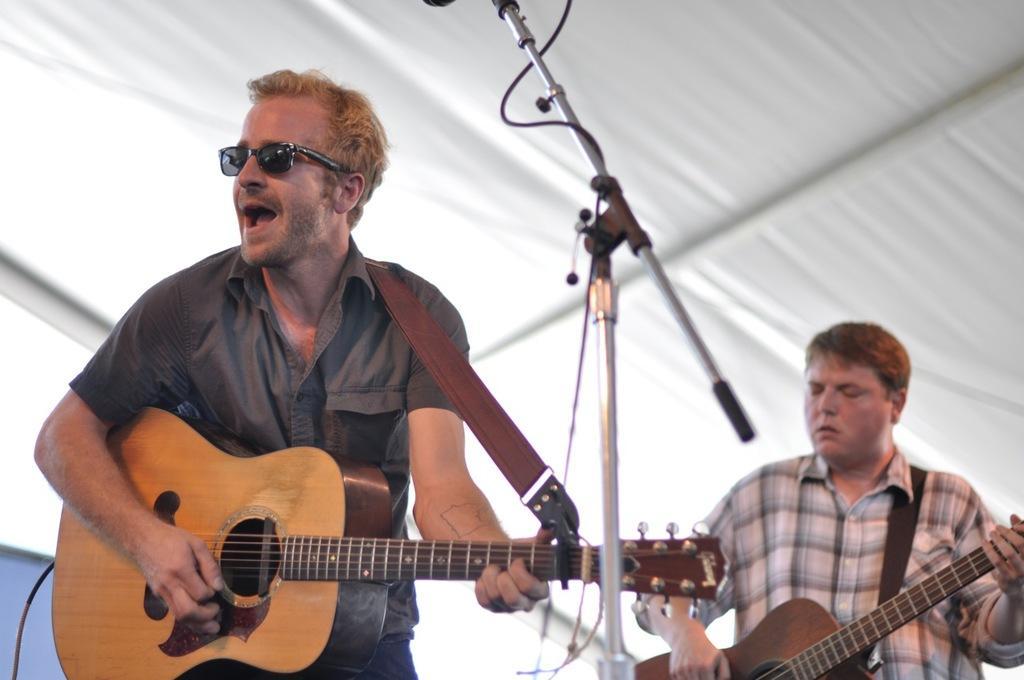In one or two sentences, can you explain what this image depicts? This picture shows a man singing and playing guitar with the help of a microphone and we see other man playing guitar. 